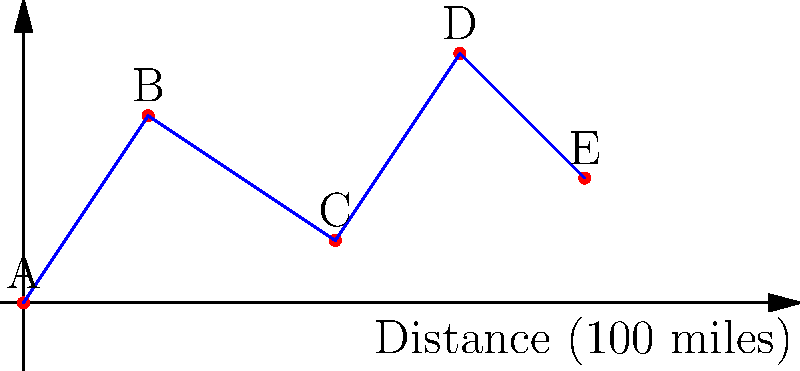As a concert promoter for Lady Antebellum's upcoming tour, you need to determine the most efficient route between five cities. The map shows cities A, B, C, D, and E, with distances proportional to 100 miles per unit. What is the total distance traveled if the tour follows the route A → B → C → D → E, and what is the average distance between consecutive cities? To solve this problem, we need to calculate the distances between consecutive cities and then sum them up. Let's break it down step by step:

1. Calculate the distance between each pair of consecutive cities:
   A to B: $\sqrt{2^2 + 3^2} = \sqrt{13} \approx 3.61$ units
   B to C: $\sqrt{3^2 + (-2)^2} = \sqrt{13} \approx 3.61$ units
   C to D: $\sqrt{2^2 + 3^2} = \sqrt{13} \approx 3.61$ units
   D to E: $\sqrt{2^2 + (-2)^2} = \sqrt{8} = 2.83$ units

2. Sum up all the distances:
   Total distance = $3.61 + 3.61 + 3.61 + 2.83 = 13.66$ units

3. Convert units to miles:
   $13.66 \times 100 = 1,366$ miles

4. Calculate the average distance between consecutive cities:
   Average distance = Total distance / (Number of segments)
   $= 1,366 / 4 = 341.5$ miles

Therefore, the total distance traveled is 1,366 miles, and the average distance between consecutive cities is 341.5 miles.
Answer: 1,366 miles total; 341.5 miles average 